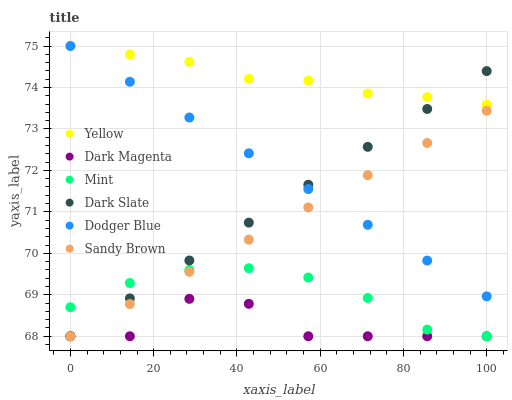Does Dark Magenta have the minimum area under the curve?
Answer yes or no. Yes. Does Yellow have the maximum area under the curve?
Answer yes or no. Yes. Does Mint have the minimum area under the curve?
Answer yes or no. No. Does Mint have the maximum area under the curve?
Answer yes or no. No. Is Dodger Blue the smoothest?
Answer yes or no. Yes. Is Dark Magenta the roughest?
Answer yes or no. Yes. Is Mint the smoothest?
Answer yes or no. No. Is Mint the roughest?
Answer yes or no. No. Does Dark Magenta have the lowest value?
Answer yes or no. Yes. Does Yellow have the lowest value?
Answer yes or no. No. Does Dodger Blue have the highest value?
Answer yes or no. Yes. Does Mint have the highest value?
Answer yes or no. No. Is Mint less than Dodger Blue?
Answer yes or no. Yes. Is Dodger Blue greater than Mint?
Answer yes or no. Yes. Does Yellow intersect Dark Slate?
Answer yes or no. Yes. Is Yellow less than Dark Slate?
Answer yes or no. No. Is Yellow greater than Dark Slate?
Answer yes or no. No. Does Mint intersect Dodger Blue?
Answer yes or no. No. 